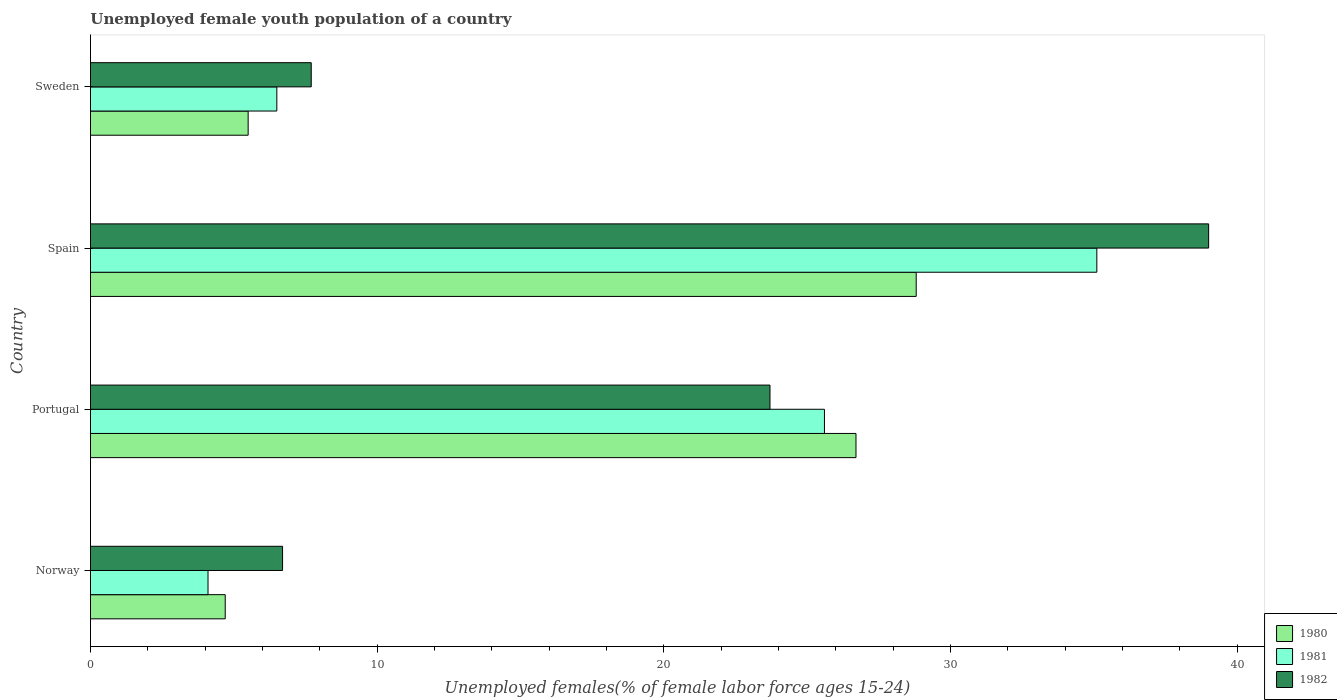How many different coloured bars are there?
Your response must be concise. 3. Are the number of bars per tick equal to the number of legend labels?
Ensure brevity in your answer.  Yes. How many bars are there on the 2nd tick from the bottom?
Keep it short and to the point. 3. In how many cases, is the number of bars for a given country not equal to the number of legend labels?
Your answer should be very brief. 0. What is the percentage of unemployed female youth population in 1981 in Portugal?
Offer a terse response. 25.6. Across all countries, what is the maximum percentage of unemployed female youth population in 1981?
Offer a terse response. 35.1. Across all countries, what is the minimum percentage of unemployed female youth population in 1981?
Your answer should be very brief. 4.1. In which country was the percentage of unemployed female youth population in 1981 maximum?
Offer a terse response. Spain. What is the total percentage of unemployed female youth population in 1982 in the graph?
Ensure brevity in your answer.  77.1. What is the difference between the percentage of unemployed female youth population in 1980 in Portugal and that in Sweden?
Your response must be concise. 21.2. What is the difference between the percentage of unemployed female youth population in 1980 in Norway and the percentage of unemployed female youth population in 1982 in Sweden?
Provide a short and direct response. -3. What is the average percentage of unemployed female youth population in 1982 per country?
Your response must be concise. 19.28. What is the difference between the percentage of unemployed female youth population in 1982 and percentage of unemployed female youth population in 1981 in Portugal?
Make the answer very short. -1.9. In how many countries, is the percentage of unemployed female youth population in 1982 greater than 14 %?
Ensure brevity in your answer.  2. What is the ratio of the percentage of unemployed female youth population in 1981 in Norway to that in Portugal?
Ensure brevity in your answer.  0.16. Is the difference between the percentage of unemployed female youth population in 1982 in Norway and Spain greater than the difference between the percentage of unemployed female youth population in 1981 in Norway and Spain?
Provide a succinct answer. No. What is the difference between the highest and the second highest percentage of unemployed female youth population in 1981?
Ensure brevity in your answer.  9.5. What is the difference between the highest and the lowest percentage of unemployed female youth population in 1982?
Ensure brevity in your answer.  32.3. In how many countries, is the percentage of unemployed female youth population in 1980 greater than the average percentage of unemployed female youth population in 1980 taken over all countries?
Give a very brief answer. 2. What does the 2nd bar from the top in Norway represents?
Keep it short and to the point. 1981. What does the 1st bar from the bottom in Spain represents?
Make the answer very short. 1980. Is it the case that in every country, the sum of the percentage of unemployed female youth population in 1982 and percentage of unemployed female youth population in 1981 is greater than the percentage of unemployed female youth population in 1980?
Give a very brief answer. Yes. How many bars are there?
Your response must be concise. 12. How many countries are there in the graph?
Your answer should be compact. 4. What is the difference between two consecutive major ticks on the X-axis?
Keep it short and to the point. 10. Does the graph contain any zero values?
Make the answer very short. No. Does the graph contain grids?
Make the answer very short. No. How are the legend labels stacked?
Offer a very short reply. Vertical. What is the title of the graph?
Provide a short and direct response. Unemployed female youth population of a country. What is the label or title of the X-axis?
Provide a succinct answer. Unemployed females(% of female labor force ages 15-24). What is the Unemployed females(% of female labor force ages 15-24) in 1980 in Norway?
Your answer should be compact. 4.7. What is the Unemployed females(% of female labor force ages 15-24) in 1981 in Norway?
Keep it short and to the point. 4.1. What is the Unemployed females(% of female labor force ages 15-24) in 1982 in Norway?
Offer a terse response. 6.7. What is the Unemployed females(% of female labor force ages 15-24) of 1980 in Portugal?
Give a very brief answer. 26.7. What is the Unemployed females(% of female labor force ages 15-24) in 1981 in Portugal?
Ensure brevity in your answer.  25.6. What is the Unemployed females(% of female labor force ages 15-24) in 1982 in Portugal?
Provide a succinct answer. 23.7. What is the Unemployed females(% of female labor force ages 15-24) in 1980 in Spain?
Your answer should be compact. 28.8. What is the Unemployed females(% of female labor force ages 15-24) in 1981 in Spain?
Provide a short and direct response. 35.1. What is the Unemployed females(% of female labor force ages 15-24) of 1982 in Spain?
Your answer should be very brief. 39. What is the Unemployed females(% of female labor force ages 15-24) of 1981 in Sweden?
Give a very brief answer. 6.5. What is the Unemployed females(% of female labor force ages 15-24) in 1982 in Sweden?
Provide a succinct answer. 7.7. Across all countries, what is the maximum Unemployed females(% of female labor force ages 15-24) of 1980?
Provide a succinct answer. 28.8. Across all countries, what is the maximum Unemployed females(% of female labor force ages 15-24) in 1981?
Ensure brevity in your answer.  35.1. Across all countries, what is the minimum Unemployed females(% of female labor force ages 15-24) in 1980?
Offer a terse response. 4.7. Across all countries, what is the minimum Unemployed females(% of female labor force ages 15-24) in 1981?
Make the answer very short. 4.1. Across all countries, what is the minimum Unemployed females(% of female labor force ages 15-24) of 1982?
Offer a very short reply. 6.7. What is the total Unemployed females(% of female labor force ages 15-24) in 1980 in the graph?
Make the answer very short. 65.7. What is the total Unemployed females(% of female labor force ages 15-24) in 1981 in the graph?
Your answer should be very brief. 71.3. What is the total Unemployed females(% of female labor force ages 15-24) in 1982 in the graph?
Give a very brief answer. 77.1. What is the difference between the Unemployed females(% of female labor force ages 15-24) in 1980 in Norway and that in Portugal?
Offer a very short reply. -22. What is the difference between the Unemployed females(% of female labor force ages 15-24) of 1981 in Norway and that in Portugal?
Ensure brevity in your answer.  -21.5. What is the difference between the Unemployed females(% of female labor force ages 15-24) in 1982 in Norway and that in Portugal?
Your answer should be compact. -17. What is the difference between the Unemployed females(% of female labor force ages 15-24) in 1980 in Norway and that in Spain?
Your answer should be very brief. -24.1. What is the difference between the Unemployed females(% of female labor force ages 15-24) in 1981 in Norway and that in Spain?
Provide a succinct answer. -31. What is the difference between the Unemployed females(% of female labor force ages 15-24) in 1982 in Norway and that in Spain?
Provide a succinct answer. -32.3. What is the difference between the Unemployed females(% of female labor force ages 15-24) of 1980 in Norway and that in Sweden?
Provide a short and direct response. -0.8. What is the difference between the Unemployed females(% of female labor force ages 15-24) of 1980 in Portugal and that in Spain?
Offer a very short reply. -2.1. What is the difference between the Unemployed females(% of female labor force ages 15-24) in 1982 in Portugal and that in Spain?
Provide a short and direct response. -15.3. What is the difference between the Unemployed females(% of female labor force ages 15-24) of 1980 in Portugal and that in Sweden?
Make the answer very short. 21.2. What is the difference between the Unemployed females(% of female labor force ages 15-24) of 1982 in Portugal and that in Sweden?
Make the answer very short. 16. What is the difference between the Unemployed females(% of female labor force ages 15-24) in 1980 in Spain and that in Sweden?
Keep it short and to the point. 23.3. What is the difference between the Unemployed females(% of female labor force ages 15-24) in 1981 in Spain and that in Sweden?
Your answer should be very brief. 28.6. What is the difference between the Unemployed females(% of female labor force ages 15-24) in 1982 in Spain and that in Sweden?
Offer a terse response. 31.3. What is the difference between the Unemployed females(% of female labor force ages 15-24) in 1980 in Norway and the Unemployed females(% of female labor force ages 15-24) in 1981 in Portugal?
Offer a very short reply. -20.9. What is the difference between the Unemployed females(% of female labor force ages 15-24) in 1981 in Norway and the Unemployed females(% of female labor force ages 15-24) in 1982 in Portugal?
Provide a succinct answer. -19.6. What is the difference between the Unemployed females(% of female labor force ages 15-24) in 1980 in Norway and the Unemployed females(% of female labor force ages 15-24) in 1981 in Spain?
Provide a succinct answer. -30.4. What is the difference between the Unemployed females(% of female labor force ages 15-24) in 1980 in Norway and the Unemployed females(% of female labor force ages 15-24) in 1982 in Spain?
Your answer should be compact. -34.3. What is the difference between the Unemployed females(% of female labor force ages 15-24) of 1981 in Norway and the Unemployed females(% of female labor force ages 15-24) of 1982 in Spain?
Provide a succinct answer. -34.9. What is the difference between the Unemployed females(% of female labor force ages 15-24) in 1980 in Norway and the Unemployed females(% of female labor force ages 15-24) in 1981 in Sweden?
Make the answer very short. -1.8. What is the difference between the Unemployed females(% of female labor force ages 15-24) of 1981 in Norway and the Unemployed females(% of female labor force ages 15-24) of 1982 in Sweden?
Offer a terse response. -3.6. What is the difference between the Unemployed females(% of female labor force ages 15-24) in 1980 in Portugal and the Unemployed females(% of female labor force ages 15-24) in 1981 in Spain?
Give a very brief answer. -8.4. What is the difference between the Unemployed females(% of female labor force ages 15-24) of 1980 in Portugal and the Unemployed females(% of female labor force ages 15-24) of 1982 in Spain?
Keep it short and to the point. -12.3. What is the difference between the Unemployed females(% of female labor force ages 15-24) in 1981 in Portugal and the Unemployed females(% of female labor force ages 15-24) in 1982 in Spain?
Ensure brevity in your answer.  -13.4. What is the difference between the Unemployed females(% of female labor force ages 15-24) of 1980 in Portugal and the Unemployed females(% of female labor force ages 15-24) of 1981 in Sweden?
Your response must be concise. 20.2. What is the difference between the Unemployed females(% of female labor force ages 15-24) of 1980 in Spain and the Unemployed females(% of female labor force ages 15-24) of 1981 in Sweden?
Give a very brief answer. 22.3. What is the difference between the Unemployed females(% of female labor force ages 15-24) in 1980 in Spain and the Unemployed females(% of female labor force ages 15-24) in 1982 in Sweden?
Your answer should be very brief. 21.1. What is the difference between the Unemployed females(% of female labor force ages 15-24) in 1981 in Spain and the Unemployed females(% of female labor force ages 15-24) in 1982 in Sweden?
Your answer should be compact. 27.4. What is the average Unemployed females(% of female labor force ages 15-24) of 1980 per country?
Offer a terse response. 16.43. What is the average Unemployed females(% of female labor force ages 15-24) in 1981 per country?
Offer a terse response. 17.82. What is the average Unemployed females(% of female labor force ages 15-24) of 1982 per country?
Keep it short and to the point. 19.27. What is the difference between the Unemployed females(% of female labor force ages 15-24) of 1980 and Unemployed females(% of female labor force ages 15-24) of 1982 in Norway?
Offer a terse response. -2. What is the difference between the Unemployed females(% of female labor force ages 15-24) of 1980 and Unemployed females(% of female labor force ages 15-24) of 1981 in Portugal?
Keep it short and to the point. 1.1. What is the difference between the Unemployed females(% of female labor force ages 15-24) of 1980 and Unemployed females(% of female labor force ages 15-24) of 1982 in Portugal?
Offer a very short reply. 3. What is the difference between the Unemployed females(% of female labor force ages 15-24) in 1981 and Unemployed females(% of female labor force ages 15-24) in 1982 in Portugal?
Provide a short and direct response. 1.9. What is the ratio of the Unemployed females(% of female labor force ages 15-24) of 1980 in Norway to that in Portugal?
Ensure brevity in your answer.  0.18. What is the ratio of the Unemployed females(% of female labor force ages 15-24) in 1981 in Norway to that in Portugal?
Keep it short and to the point. 0.16. What is the ratio of the Unemployed females(% of female labor force ages 15-24) in 1982 in Norway to that in Portugal?
Your answer should be very brief. 0.28. What is the ratio of the Unemployed females(% of female labor force ages 15-24) of 1980 in Norway to that in Spain?
Provide a short and direct response. 0.16. What is the ratio of the Unemployed females(% of female labor force ages 15-24) of 1981 in Norway to that in Spain?
Keep it short and to the point. 0.12. What is the ratio of the Unemployed females(% of female labor force ages 15-24) of 1982 in Norway to that in Spain?
Keep it short and to the point. 0.17. What is the ratio of the Unemployed females(% of female labor force ages 15-24) in 1980 in Norway to that in Sweden?
Make the answer very short. 0.85. What is the ratio of the Unemployed females(% of female labor force ages 15-24) of 1981 in Norway to that in Sweden?
Offer a terse response. 0.63. What is the ratio of the Unemployed females(% of female labor force ages 15-24) of 1982 in Norway to that in Sweden?
Make the answer very short. 0.87. What is the ratio of the Unemployed females(% of female labor force ages 15-24) in 1980 in Portugal to that in Spain?
Give a very brief answer. 0.93. What is the ratio of the Unemployed females(% of female labor force ages 15-24) in 1981 in Portugal to that in Spain?
Your response must be concise. 0.73. What is the ratio of the Unemployed females(% of female labor force ages 15-24) of 1982 in Portugal to that in Spain?
Offer a terse response. 0.61. What is the ratio of the Unemployed females(% of female labor force ages 15-24) in 1980 in Portugal to that in Sweden?
Provide a succinct answer. 4.85. What is the ratio of the Unemployed females(% of female labor force ages 15-24) in 1981 in Portugal to that in Sweden?
Ensure brevity in your answer.  3.94. What is the ratio of the Unemployed females(% of female labor force ages 15-24) in 1982 in Portugal to that in Sweden?
Offer a very short reply. 3.08. What is the ratio of the Unemployed females(% of female labor force ages 15-24) of 1980 in Spain to that in Sweden?
Make the answer very short. 5.24. What is the ratio of the Unemployed females(% of female labor force ages 15-24) of 1981 in Spain to that in Sweden?
Your answer should be very brief. 5.4. What is the ratio of the Unemployed females(% of female labor force ages 15-24) in 1982 in Spain to that in Sweden?
Your answer should be compact. 5.06. What is the difference between the highest and the second highest Unemployed females(% of female labor force ages 15-24) in 1980?
Provide a short and direct response. 2.1. What is the difference between the highest and the second highest Unemployed females(% of female labor force ages 15-24) of 1981?
Offer a very short reply. 9.5. What is the difference between the highest and the second highest Unemployed females(% of female labor force ages 15-24) of 1982?
Keep it short and to the point. 15.3. What is the difference between the highest and the lowest Unemployed females(% of female labor force ages 15-24) of 1980?
Give a very brief answer. 24.1. What is the difference between the highest and the lowest Unemployed females(% of female labor force ages 15-24) in 1982?
Your answer should be very brief. 32.3. 